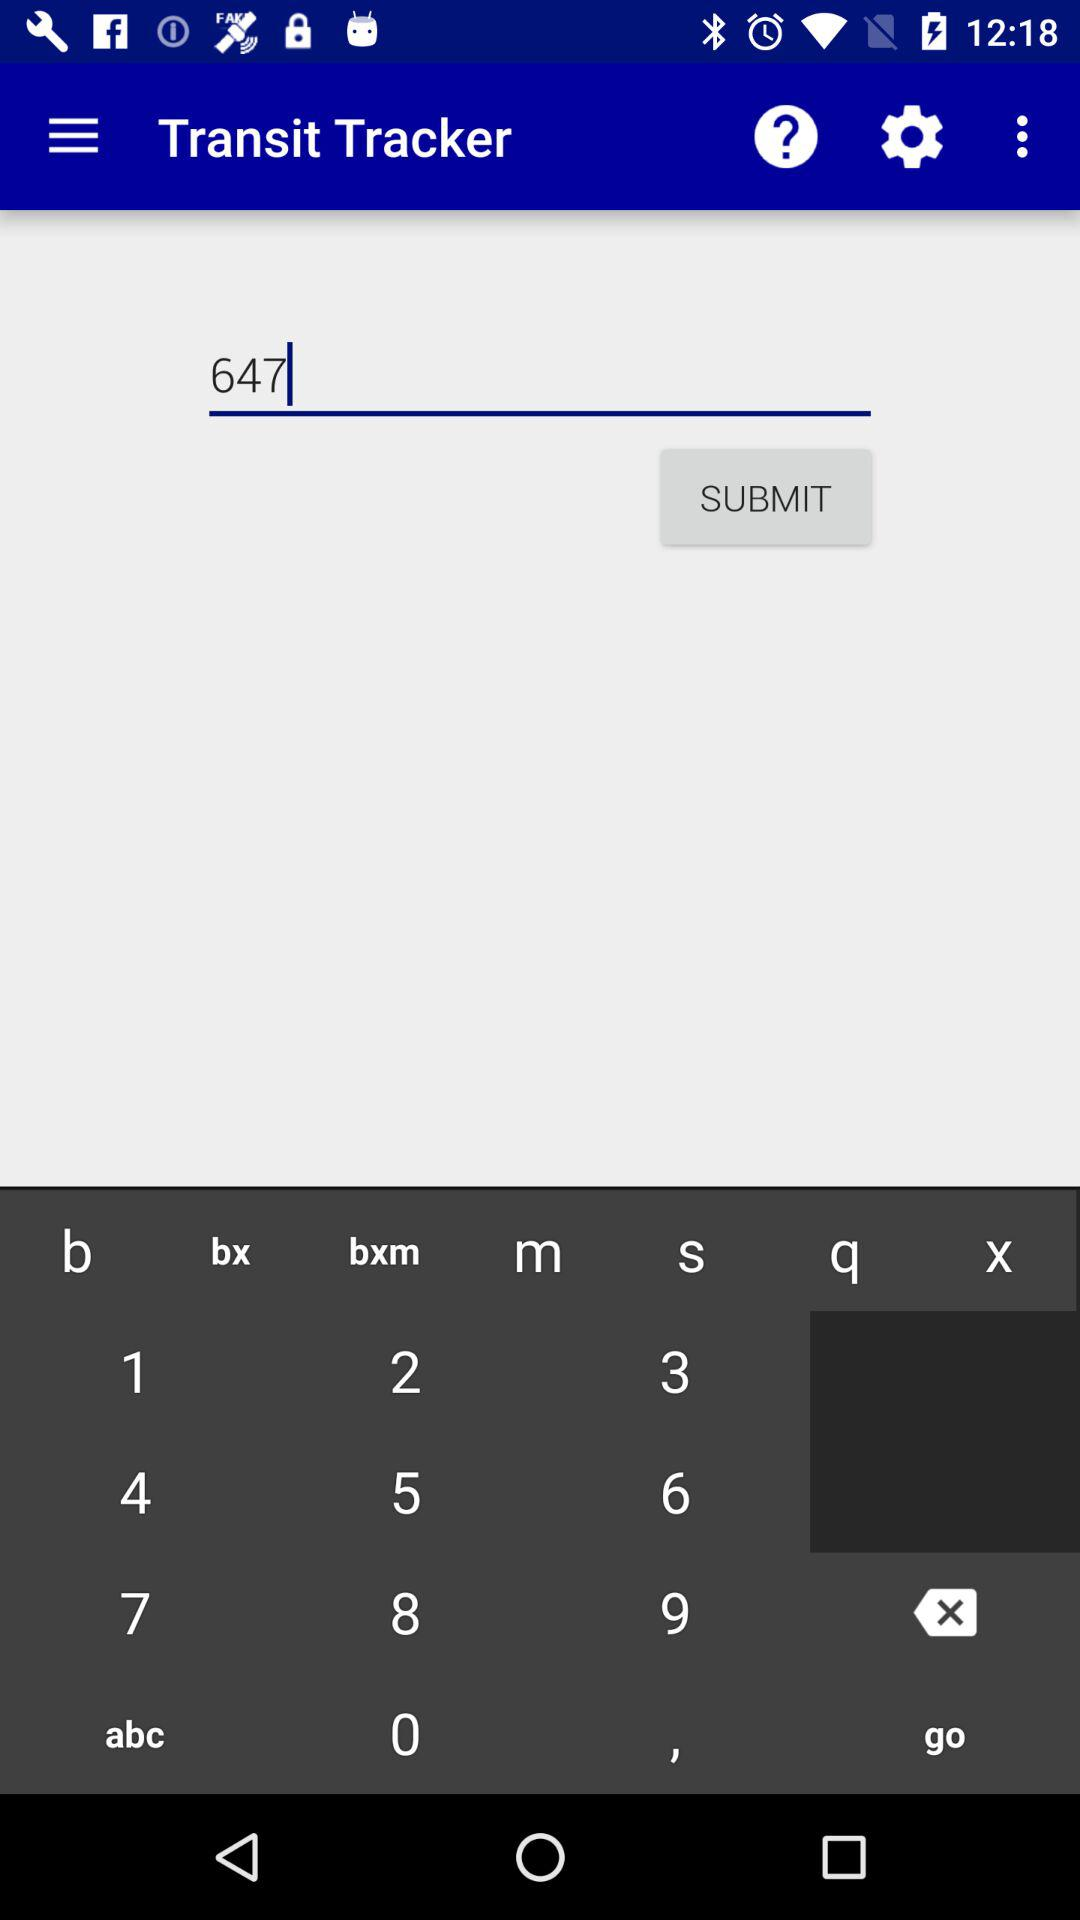What's the application name? The application name is "Transit Tracker". 